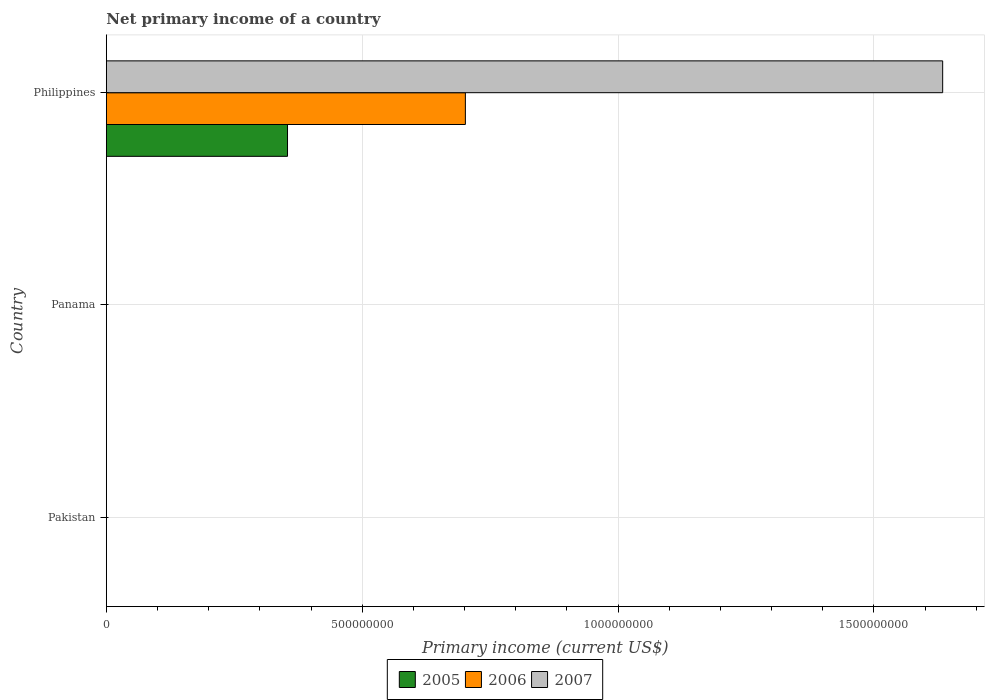How many different coloured bars are there?
Your answer should be compact. 3. How many bars are there on the 3rd tick from the bottom?
Make the answer very short. 3. What is the primary income in 2006 in Philippines?
Offer a very short reply. 7.02e+08. Across all countries, what is the maximum primary income in 2006?
Your answer should be compact. 7.02e+08. What is the total primary income in 2006 in the graph?
Provide a succinct answer. 7.02e+08. What is the difference between the primary income in 2005 in Panama and the primary income in 2006 in Philippines?
Your answer should be compact. -7.02e+08. What is the average primary income in 2007 per country?
Your answer should be compact. 5.45e+08. What is the difference between the primary income in 2005 and primary income in 2006 in Philippines?
Offer a terse response. -3.48e+08. What is the difference between the highest and the lowest primary income in 2006?
Offer a terse response. 7.02e+08. In how many countries, is the primary income in 2006 greater than the average primary income in 2006 taken over all countries?
Ensure brevity in your answer.  1. Is it the case that in every country, the sum of the primary income in 2005 and primary income in 2007 is greater than the primary income in 2006?
Offer a very short reply. No. How are the legend labels stacked?
Your answer should be very brief. Horizontal. What is the title of the graph?
Your response must be concise. Net primary income of a country. Does "2003" appear as one of the legend labels in the graph?
Ensure brevity in your answer.  No. What is the label or title of the X-axis?
Offer a very short reply. Primary income (current US$). What is the Primary income (current US$) in 2005 in Pakistan?
Your answer should be compact. 0. What is the Primary income (current US$) in 2006 in Pakistan?
Keep it short and to the point. 0. What is the Primary income (current US$) of 2007 in Pakistan?
Ensure brevity in your answer.  0. What is the Primary income (current US$) in 2005 in Panama?
Your answer should be very brief. 0. What is the Primary income (current US$) of 2006 in Panama?
Offer a very short reply. 0. What is the Primary income (current US$) in 2007 in Panama?
Your response must be concise. 0. What is the Primary income (current US$) of 2005 in Philippines?
Give a very brief answer. 3.54e+08. What is the Primary income (current US$) in 2006 in Philippines?
Your answer should be compact. 7.02e+08. What is the Primary income (current US$) of 2007 in Philippines?
Offer a terse response. 1.63e+09. Across all countries, what is the maximum Primary income (current US$) in 2005?
Offer a very short reply. 3.54e+08. Across all countries, what is the maximum Primary income (current US$) of 2006?
Give a very brief answer. 7.02e+08. Across all countries, what is the maximum Primary income (current US$) in 2007?
Make the answer very short. 1.63e+09. Across all countries, what is the minimum Primary income (current US$) in 2007?
Give a very brief answer. 0. What is the total Primary income (current US$) in 2005 in the graph?
Your answer should be compact. 3.54e+08. What is the total Primary income (current US$) in 2006 in the graph?
Keep it short and to the point. 7.02e+08. What is the total Primary income (current US$) in 2007 in the graph?
Provide a succinct answer. 1.63e+09. What is the average Primary income (current US$) in 2005 per country?
Provide a short and direct response. 1.18e+08. What is the average Primary income (current US$) in 2006 per country?
Make the answer very short. 2.34e+08. What is the average Primary income (current US$) of 2007 per country?
Provide a succinct answer. 5.45e+08. What is the difference between the Primary income (current US$) of 2005 and Primary income (current US$) of 2006 in Philippines?
Give a very brief answer. -3.48e+08. What is the difference between the Primary income (current US$) in 2005 and Primary income (current US$) in 2007 in Philippines?
Offer a terse response. -1.28e+09. What is the difference between the Primary income (current US$) of 2006 and Primary income (current US$) of 2007 in Philippines?
Your response must be concise. -9.33e+08. What is the difference between the highest and the lowest Primary income (current US$) in 2005?
Provide a short and direct response. 3.54e+08. What is the difference between the highest and the lowest Primary income (current US$) of 2006?
Your response must be concise. 7.02e+08. What is the difference between the highest and the lowest Primary income (current US$) of 2007?
Your response must be concise. 1.63e+09. 